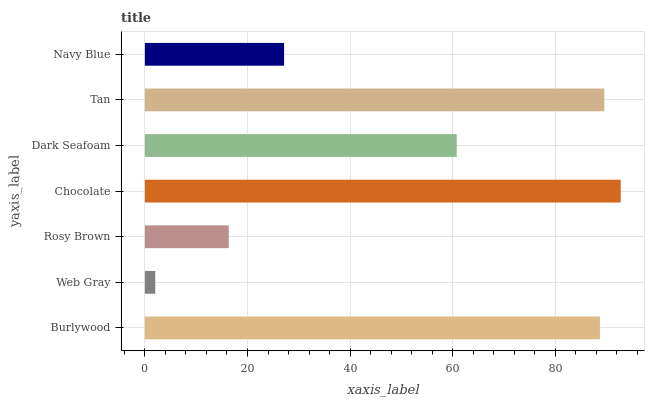Is Web Gray the minimum?
Answer yes or no. Yes. Is Chocolate the maximum?
Answer yes or no. Yes. Is Rosy Brown the minimum?
Answer yes or no. No. Is Rosy Brown the maximum?
Answer yes or no. No. Is Rosy Brown greater than Web Gray?
Answer yes or no. Yes. Is Web Gray less than Rosy Brown?
Answer yes or no. Yes. Is Web Gray greater than Rosy Brown?
Answer yes or no. No. Is Rosy Brown less than Web Gray?
Answer yes or no. No. Is Dark Seafoam the high median?
Answer yes or no. Yes. Is Dark Seafoam the low median?
Answer yes or no. Yes. Is Rosy Brown the high median?
Answer yes or no. No. Is Burlywood the low median?
Answer yes or no. No. 